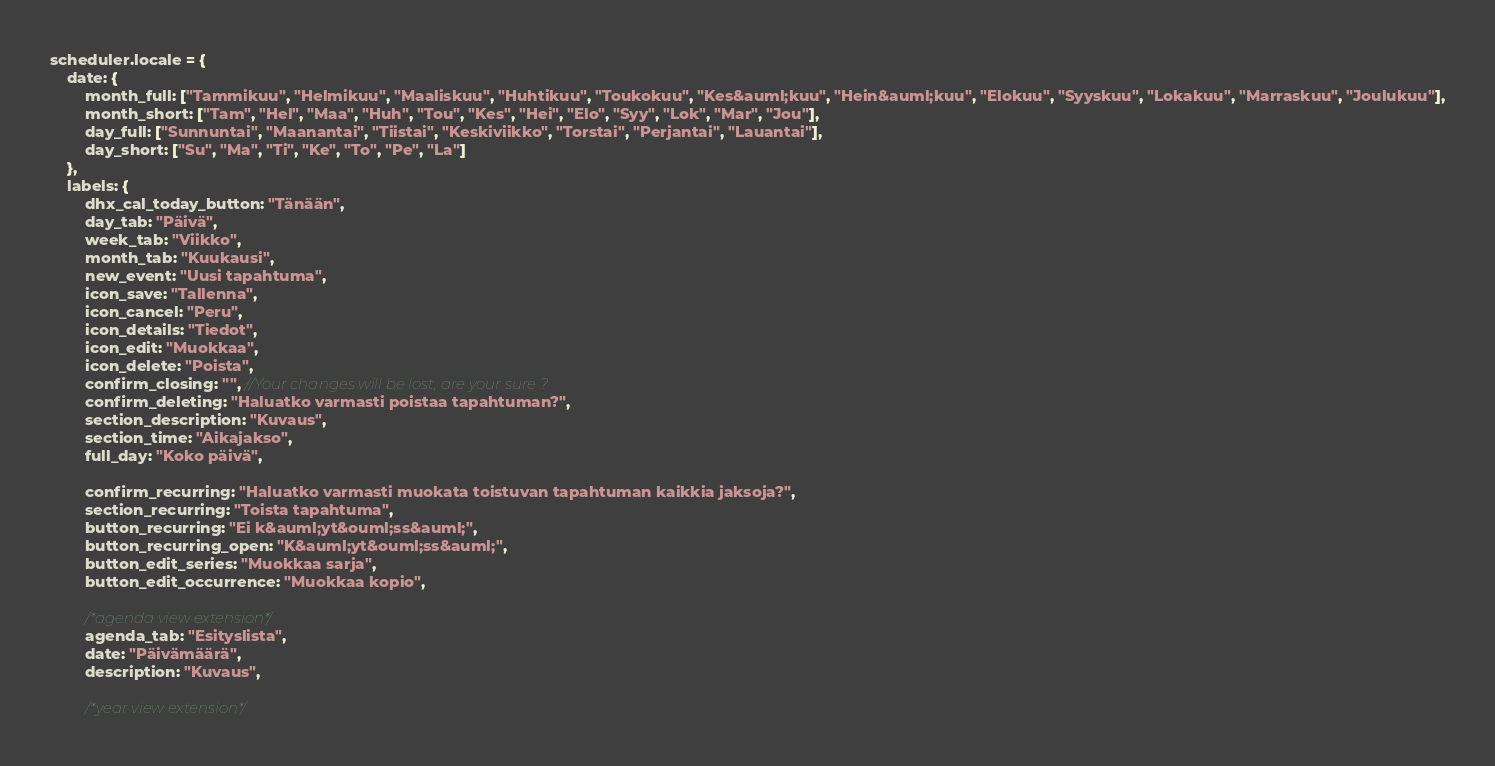<code> <loc_0><loc_0><loc_500><loc_500><_JavaScript_>scheduler.locale = {
	date: {
		month_full: ["Tammikuu", "Helmikuu", "Maaliskuu", "Huhtikuu", "Toukokuu", "Kes&auml;kuu", "Hein&auml;kuu", "Elokuu", "Syyskuu", "Lokakuu", "Marraskuu", "Joulukuu"],
		month_short: ["Tam", "Hel", "Maa", "Huh", "Tou", "Kes", "Hei", "Elo", "Syy", "Lok", "Mar", "Jou"],
		day_full: ["Sunnuntai", "Maanantai", "Tiistai", "Keskiviikko", "Torstai", "Perjantai", "Lauantai"],
		day_short: ["Su", "Ma", "Ti", "Ke", "To", "Pe", "La"]
	},
	labels: {
		dhx_cal_today_button: "Tänään",
		day_tab: "Päivä",
		week_tab: "Viikko",
		month_tab: "Kuukausi",
		new_event: "Uusi tapahtuma",
		icon_save: "Tallenna",
		icon_cancel: "Peru",
		icon_details: "Tiedot",
		icon_edit: "Muokkaa",
		icon_delete: "Poista",
		confirm_closing: "", //Your changes will be lost, are your sure ?
		confirm_deleting: "Haluatko varmasti poistaa tapahtuman?",
		section_description: "Kuvaus",
		section_time: "Aikajakso",
		full_day: "Koko päivä",

		confirm_recurring: "Haluatko varmasti muokata toistuvan tapahtuman kaikkia jaksoja?",
		section_recurring: "Toista tapahtuma",
		button_recurring: "Ei k&auml;yt&ouml;ss&auml;",
		button_recurring_open: "K&auml;yt&ouml;ss&auml;",
		button_edit_series: "Muokkaa sarja",
		button_edit_occurrence: "Muokkaa kopio",

		/*agenda view extension*/
		agenda_tab: "Esityslista",
		date: "Päivämäärä",
		description: "Kuvaus",

		/*year view extension*/</code> 